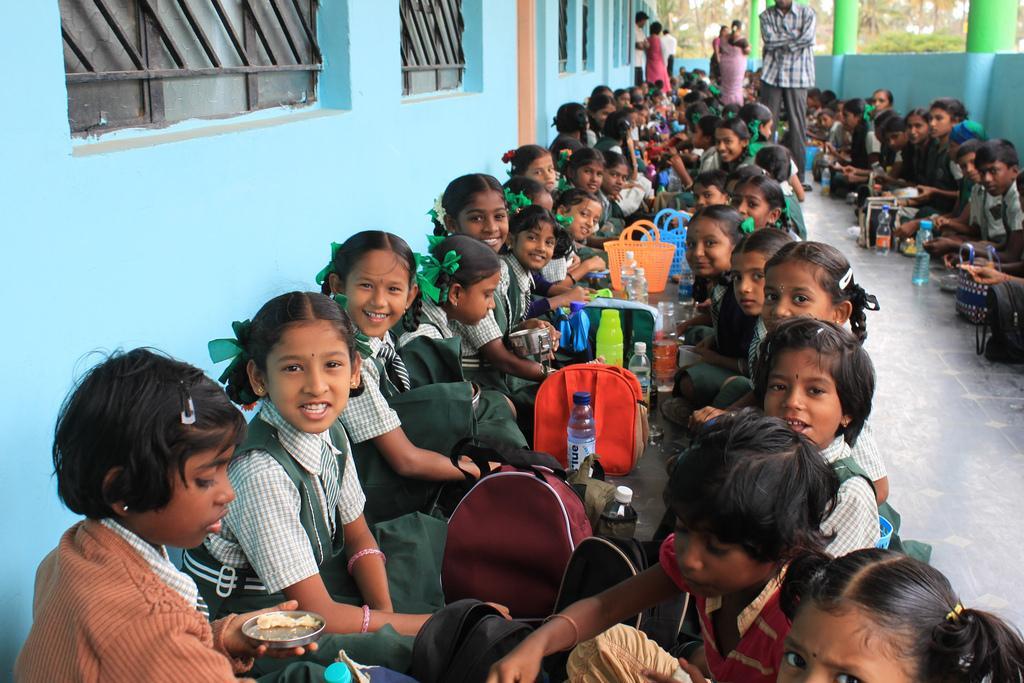How would you summarize this image in a sentence or two? In this picture we can see some children sitting on the floor. Here we can see some bags, bottles, and baskets. On the background we can see some persons standing on the floor. And this is wall. 